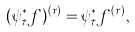<formula> <loc_0><loc_0><loc_500><loc_500>( \psi _ { \tau } ^ { * } f ) ^ { ( r ) } = \psi _ { \tau } ^ { * } f ^ { ( r ) } ,</formula> 